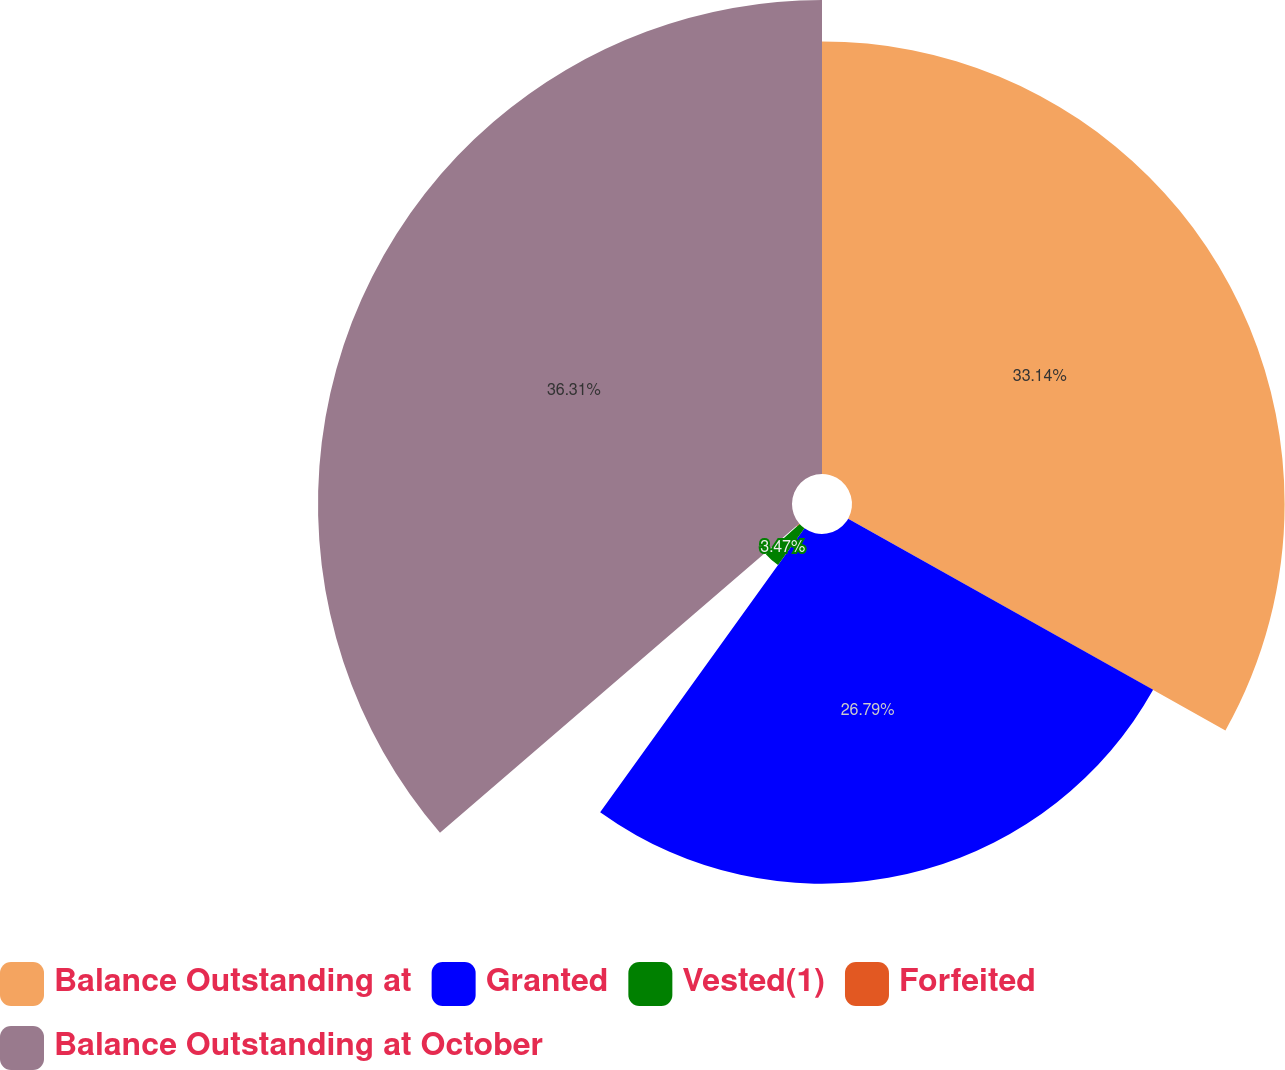Convert chart. <chart><loc_0><loc_0><loc_500><loc_500><pie_chart><fcel>Balance Outstanding at<fcel>Granted<fcel>Vested(1)<fcel>Forfeited<fcel>Balance Outstanding at October<nl><fcel>33.14%<fcel>26.79%<fcel>3.47%<fcel>0.29%<fcel>36.31%<nl></chart> 